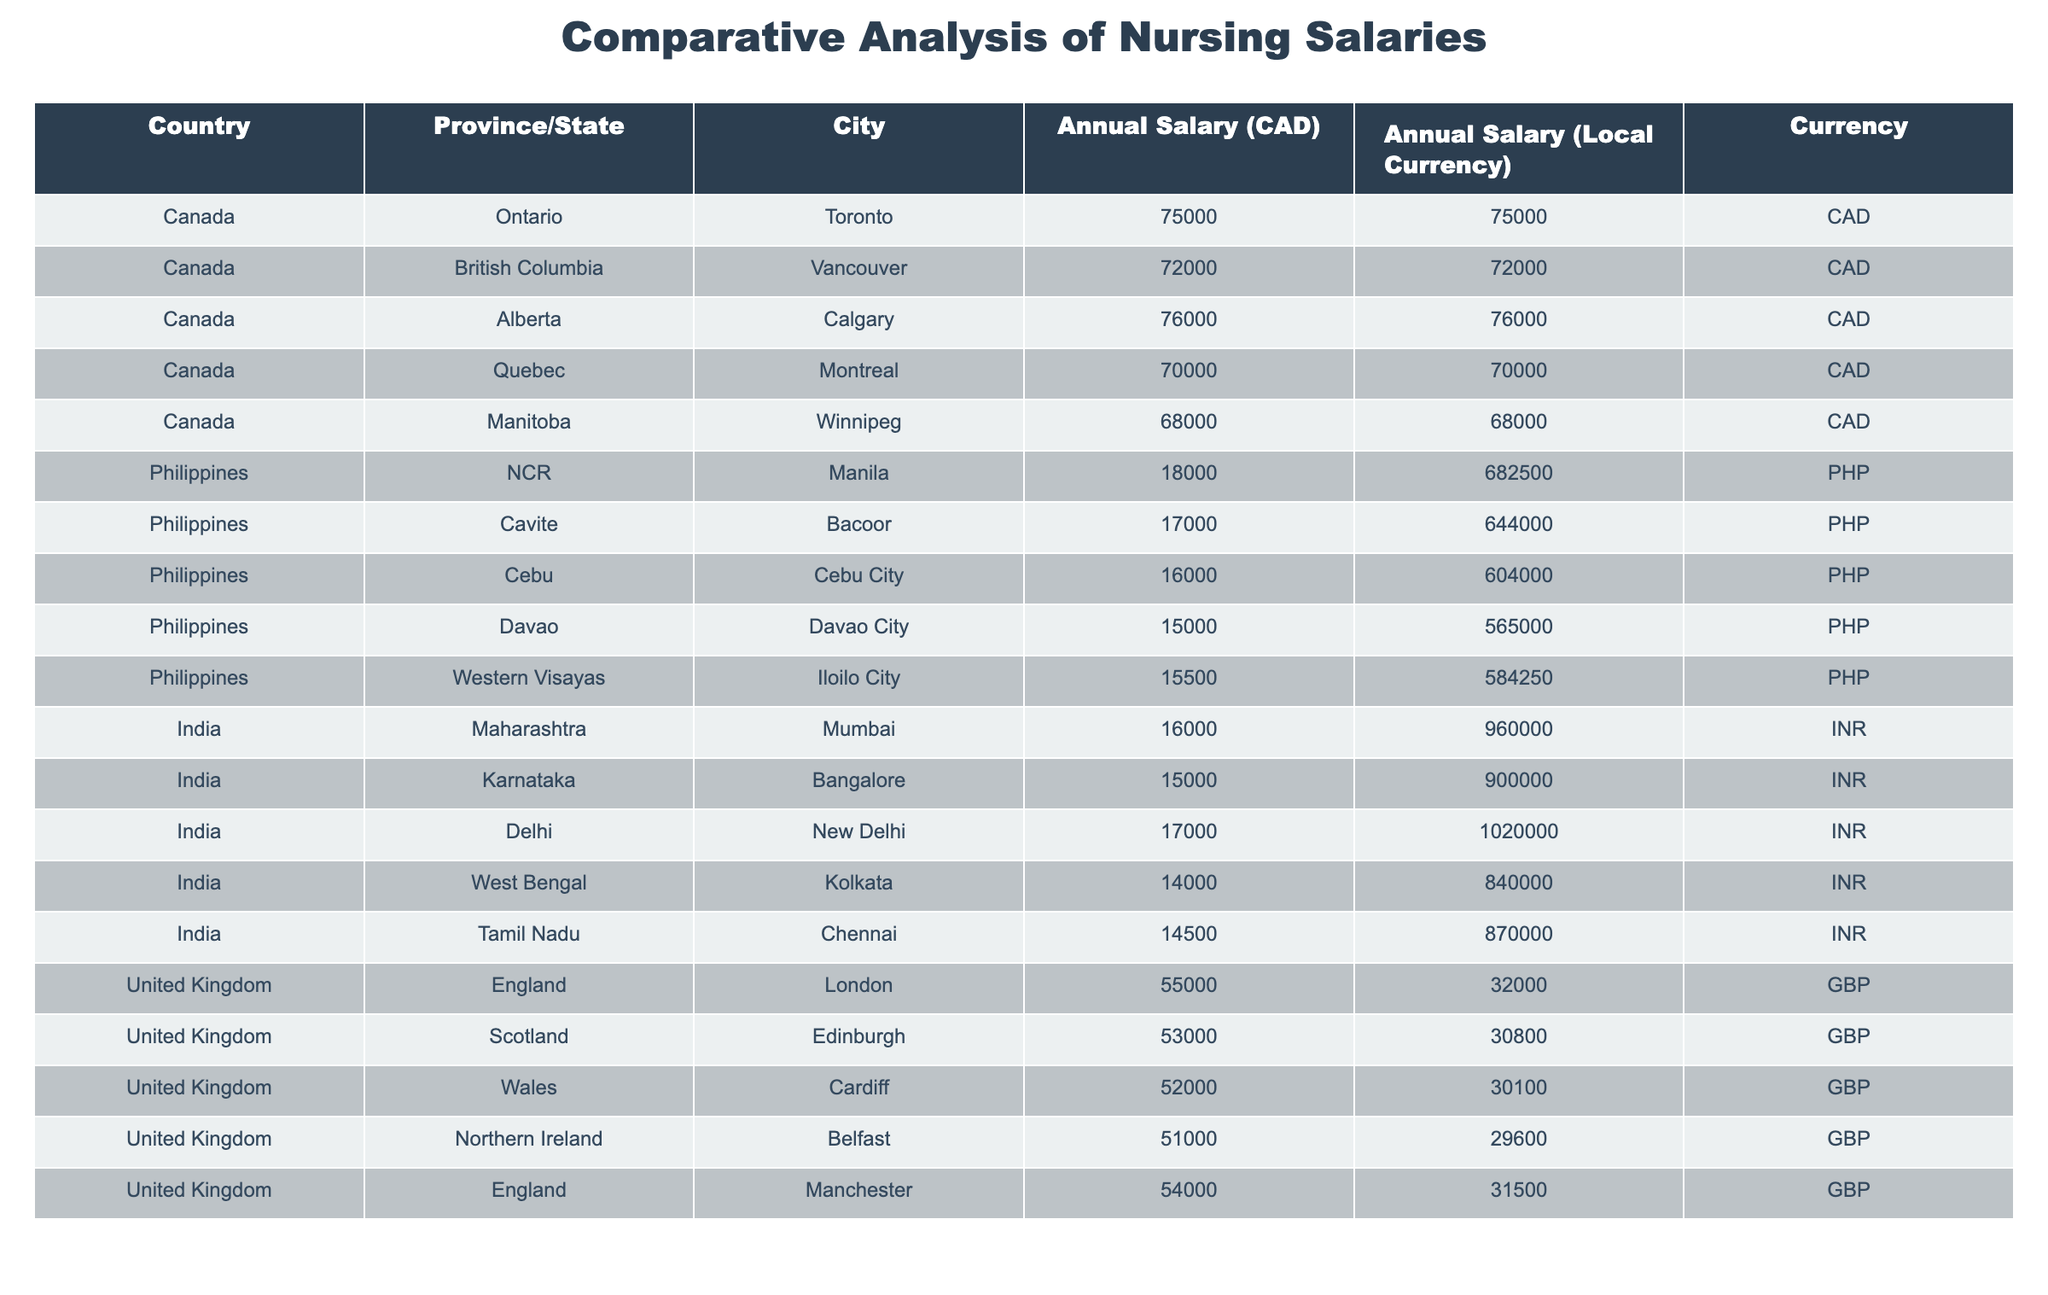What is the highest annual salary among the nursing salaries in Canada? By scanning the "Annual Salary (CAD)" column, I see that the highest salary belongs to Calgary, Alberta, which is 76000 CAD.
Answer: 76000 CAD Which city has the lowest annual salary in the Philippines? Reviewing the "Annual Salary (Local Currency)" column for the Philippines, Davao City has the lowest salary of 15000 PHP.
Answer: 15000 PHP What is the average annual salary for nursing in India across all listed cities? To find the average, I sum the salaries for the listed cities: (16000 + 15000 + 17000 + 14000 + 14500) = 76500. Dividing by the number of cities (5), the average annual salary for nursing in India is 76500 / 5 = 15300 INR.
Answer: 15300 INR Is the average annual salary for nurses in Canada higher than in the Philippines? The average annual salary for Canada can be computed as (75000 + 72000 + 76000 + 70000 + 68000) = 391000, divided by 5 yields 78200 CAD. In the Philippines, the average can be calculated as (18000 + 17000 + 16000 + 15000 + 15500) = 91500, divided by 5 gives 18300 PHP. Since 78200 CAD (converted to PHP also shows a much higher value) is more than 18300 PHP, the answer is yes, Canadian salaries are higher.
Answer: Yes Which province in Canada offers the highest annual salary? According to the table, Alberta (Calgary) has the highest annual salary of 76000 CAD.
Answer: Alberta If I convert the annual salary in Toronto to Philippine Pesos, how much would it be? The annual salary in Toronto is 75000 CAD. Converting this to PHP requires knowing the exchange rate; however, if assuming 1 CAD = 9.1 PHP (approximate), the calculation is 75000 * 9.1 = 682500 PHP.
Answer: 682500 PHP 